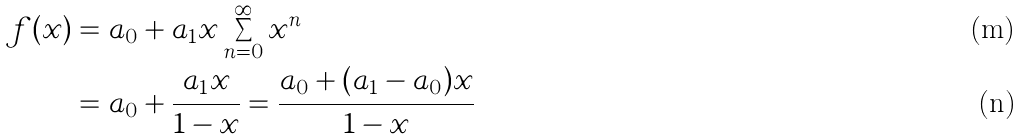<formula> <loc_0><loc_0><loc_500><loc_500>f ( x ) & = a _ { 0 } + a _ { 1 } x \sum _ { n = 0 } ^ { \infty } x ^ { n } \\ & = a _ { 0 } + \frac { a _ { 1 } x } { 1 - x } = \frac { a _ { 0 } + ( a _ { 1 } - a _ { 0 } ) x } { 1 - x }</formula> 